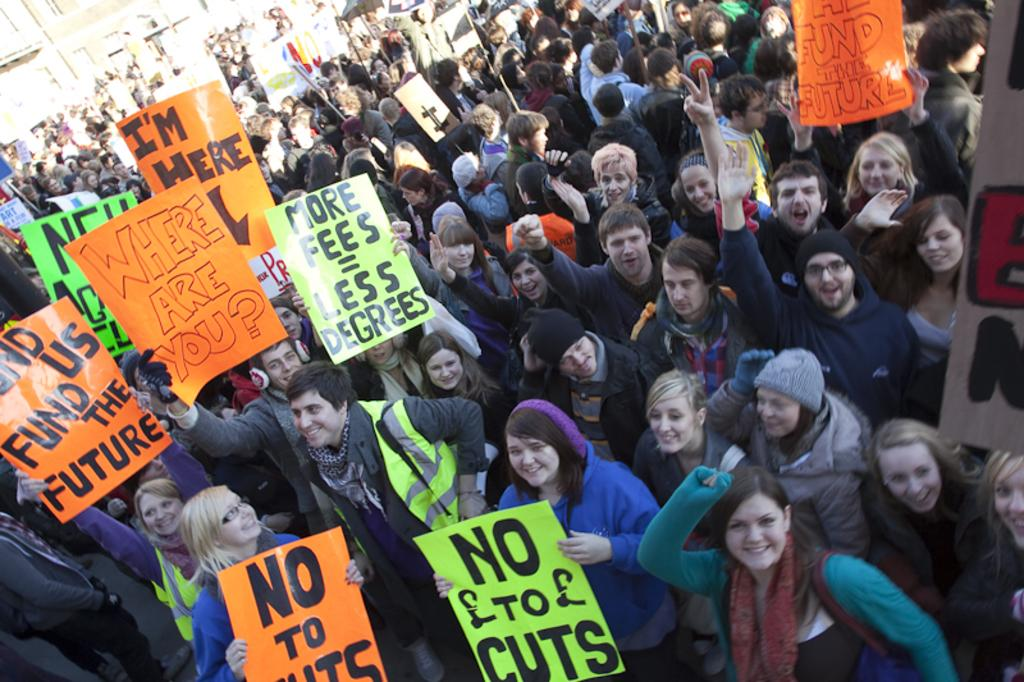How many people are in the image? There is a group of people in the image, but the exact number is not specified. What objects can be seen in the image besides the people? There are boards visible in the image. What type of skirt is the pot wearing in the image? There is no skirt or pot present in the image. 